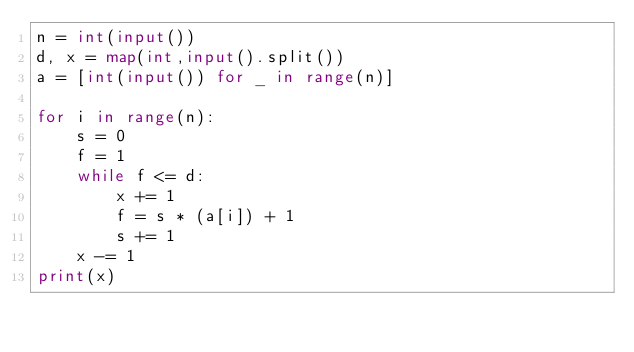<code> <loc_0><loc_0><loc_500><loc_500><_Python_>n = int(input())
d, x = map(int,input().split())
a = [int(input()) for _ in range(n)]

for i in range(n):
    s = 0
    f = 1
    while f <= d:
        x += 1
        f = s * (a[i]) + 1
        s += 1
    x -= 1
print(x)</code> 